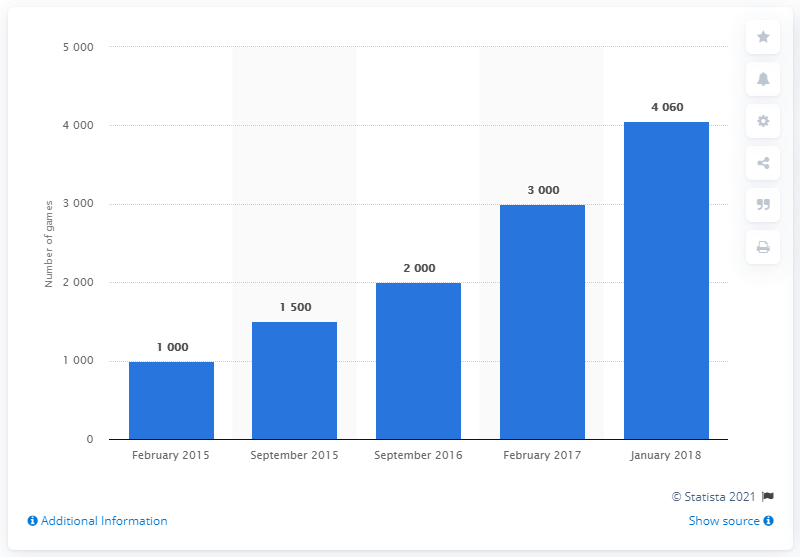Indicate a few pertinent items in this graphic. The last time Linux games were available on Steam was in January 2018. 